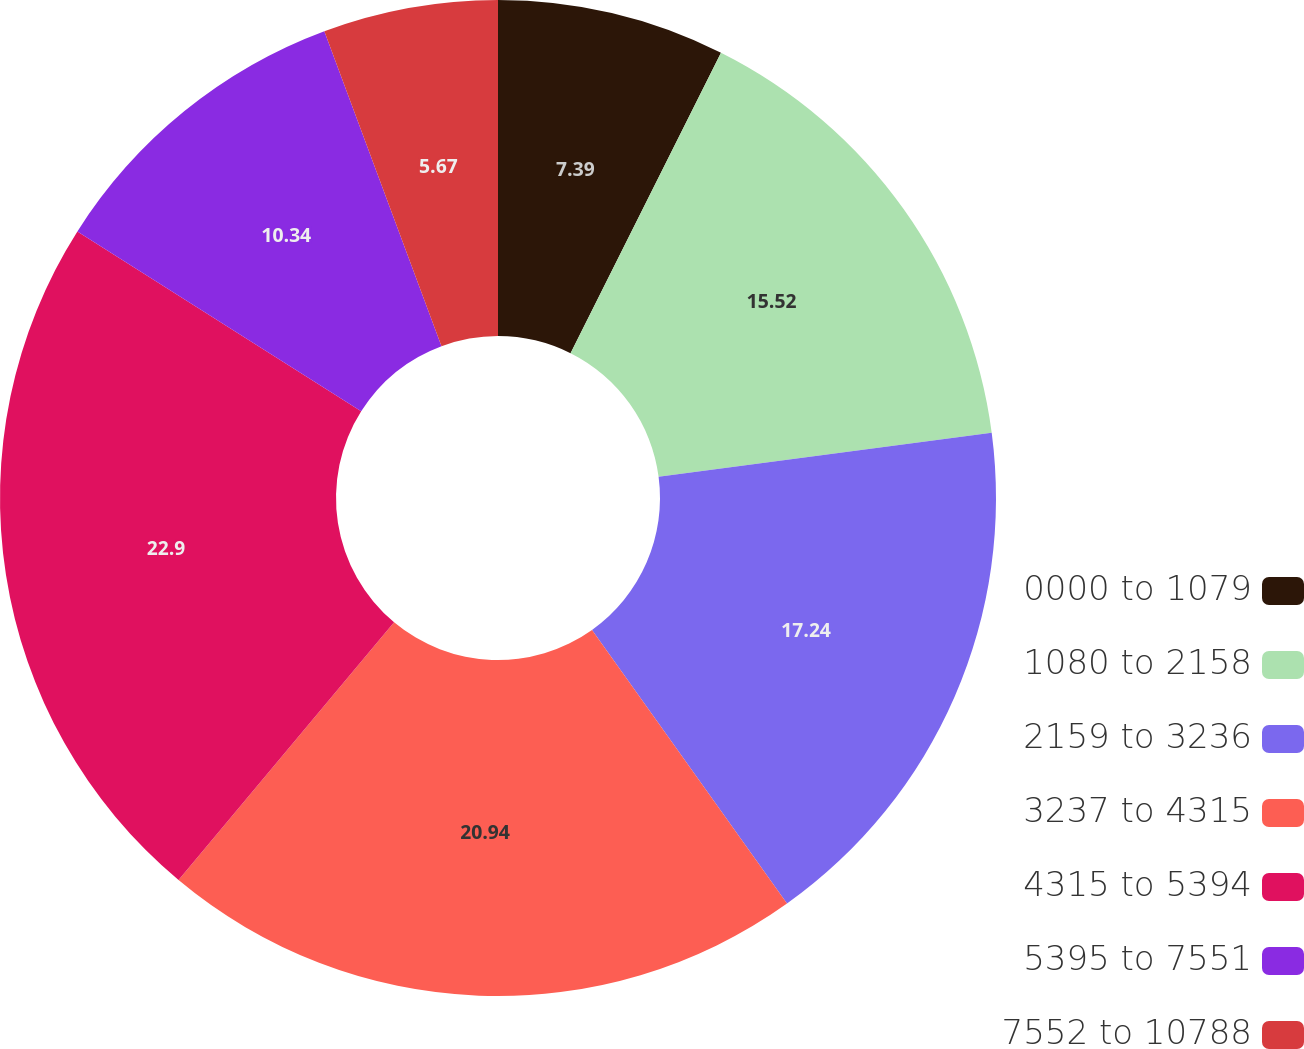Convert chart. <chart><loc_0><loc_0><loc_500><loc_500><pie_chart><fcel>0000 to 1079<fcel>1080 to 2158<fcel>2159 to 3236<fcel>3237 to 4315<fcel>4315 to 5394<fcel>5395 to 7551<fcel>7552 to 10788<nl><fcel>7.39%<fcel>15.52%<fcel>17.24%<fcel>20.94%<fcel>22.91%<fcel>10.34%<fcel>5.67%<nl></chart> 